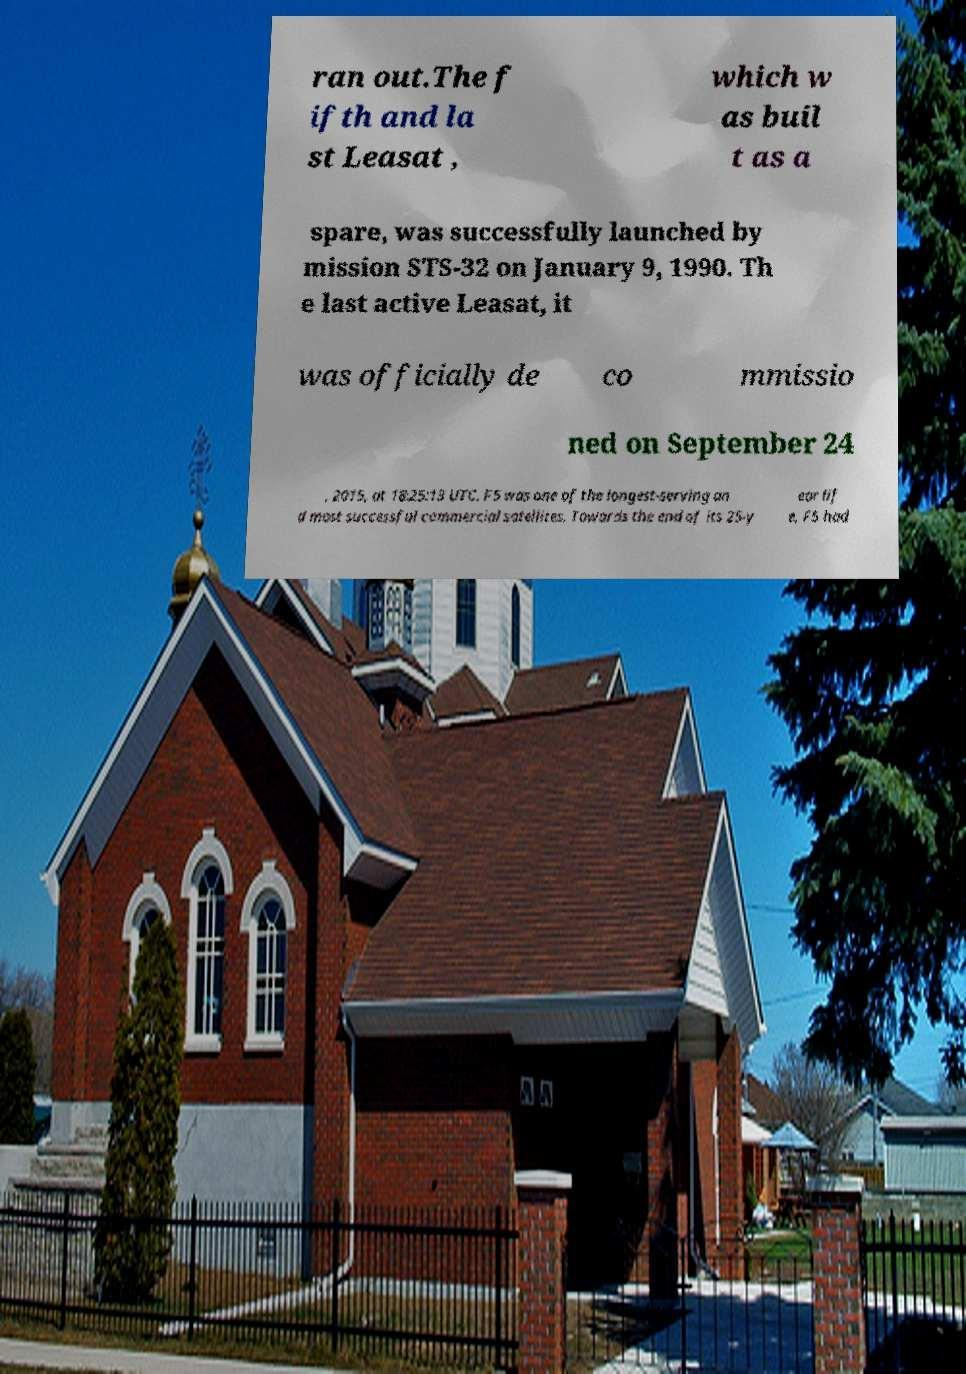Could you assist in decoding the text presented in this image and type it out clearly? ran out.The f ifth and la st Leasat , which w as buil t as a spare, was successfully launched by mission STS-32 on January 9, 1990. Th e last active Leasat, it was officially de co mmissio ned on September 24 , 2015, at 18:25:13 UTC. F5 was one of the longest-serving an d most successful commercial satellites. Towards the end of its 25-y ear lif e, F5 had 